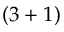Convert formula to latex. <formula><loc_0><loc_0><loc_500><loc_500>( 3 + 1 )</formula> 